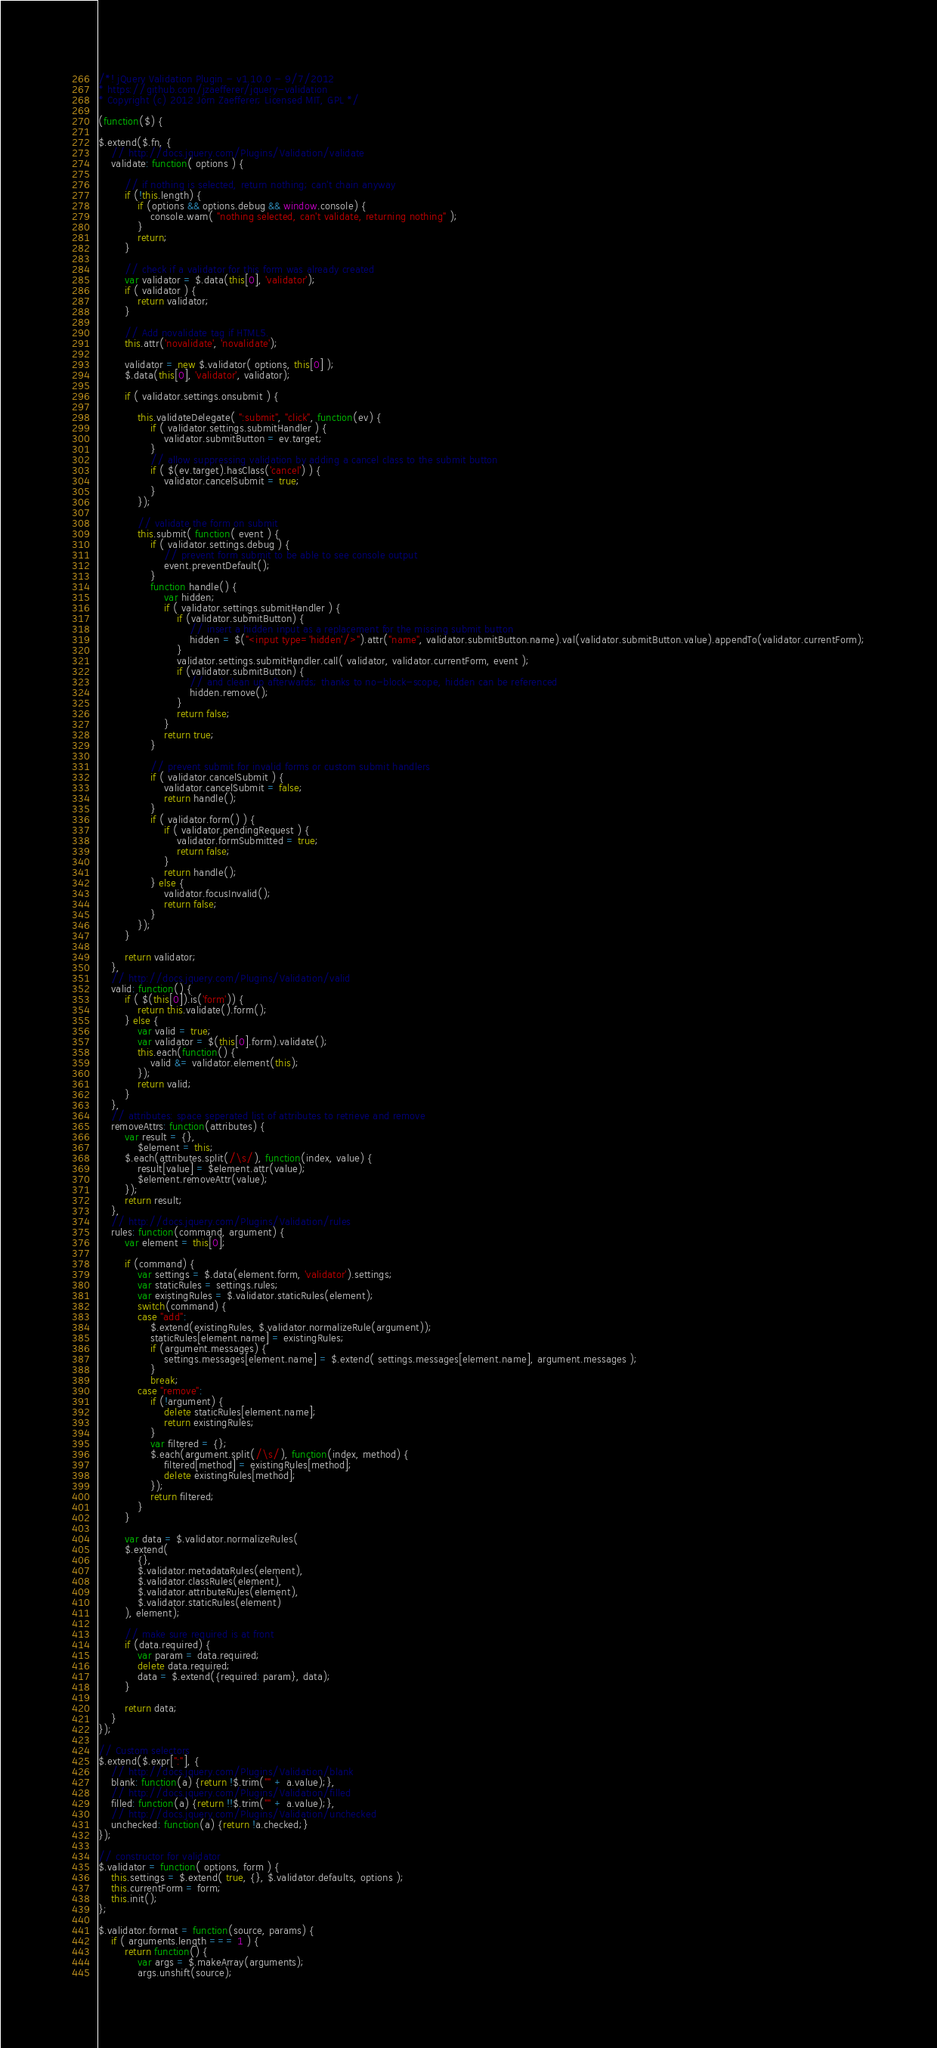Convert code to text. <code><loc_0><loc_0><loc_500><loc_500><_JavaScript_>/*! jQuery Validation Plugin - v1.10.0 - 9/7/2012
* https://github.com/jzaefferer/jquery-validation
* Copyright (c) 2012 Jörn Zaefferer; Licensed MIT, GPL */

(function($) {

$.extend($.fn, {
	// http://docs.jquery.com/Plugins/Validation/validate
	validate: function( options ) {

		// if nothing is selected, return nothing; can't chain anyway
		if (!this.length) {
			if (options && options.debug && window.console) {
				console.warn( "nothing selected, can't validate, returning nothing" );
			}
			return;
		}

		// check if a validator for this form was already created
		var validator = $.data(this[0], 'validator');
		if ( validator ) {
			return validator;
		}

		// Add novalidate tag if HTML5.
		this.attr('novalidate', 'novalidate');

		validator = new $.validator( options, this[0] );
		$.data(this[0], 'validator', validator);

		if ( validator.settings.onsubmit ) {

			this.validateDelegate( ":submit", "click", function(ev) {
				if ( validator.settings.submitHandler ) {
					validator.submitButton = ev.target;
				}
				// allow suppressing validation by adding a cancel class to the submit button
				if ( $(ev.target).hasClass('cancel') ) {
					validator.cancelSubmit = true;
				}
			});

			// validate the form on submit
			this.submit( function( event ) {
				if ( validator.settings.debug ) {
					// prevent form submit to be able to see console output
					event.preventDefault();
				}
				function handle() {
					var hidden;
					if ( validator.settings.submitHandler ) {
						if (validator.submitButton) {
							// insert a hidden input as a replacement for the missing submit button
							hidden = $("<input type='hidden'/>").attr("name", validator.submitButton.name).val(validator.submitButton.value).appendTo(validator.currentForm);
						}
						validator.settings.submitHandler.call( validator, validator.currentForm, event );
						if (validator.submitButton) {
							// and clean up afterwards; thanks to no-block-scope, hidden can be referenced
							hidden.remove();
						}
						return false;
					}
					return true;
				}

				// prevent submit for invalid forms or custom submit handlers
				if ( validator.cancelSubmit ) {
					validator.cancelSubmit = false;
					return handle();
				}
				if ( validator.form() ) {
					if ( validator.pendingRequest ) {
						validator.formSubmitted = true;
						return false;
					}
					return handle();
				} else {
					validator.focusInvalid();
					return false;
				}
			});
		}

		return validator;
	},
	// http://docs.jquery.com/Plugins/Validation/valid
	valid: function() {
		if ( $(this[0]).is('form')) {
			return this.validate().form();
		} else {
			var valid = true;
			var validator = $(this[0].form).validate();
			this.each(function() {
				valid &= validator.element(this);
			});
			return valid;
		}
	},
	// attributes: space seperated list of attributes to retrieve and remove
	removeAttrs: function(attributes) {
		var result = {},
			$element = this;
		$.each(attributes.split(/\s/), function(index, value) {
			result[value] = $element.attr(value);
			$element.removeAttr(value);
		});
		return result;
	},
	// http://docs.jquery.com/Plugins/Validation/rules
	rules: function(command, argument) {
		var element = this[0];

		if (command) {
			var settings = $.data(element.form, 'validator').settings;
			var staticRules = settings.rules;
			var existingRules = $.validator.staticRules(element);
			switch(command) {
			case "add":
				$.extend(existingRules, $.validator.normalizeRule(argument));
				staticRules[element.name] = existingRules;
				if (argument.messages) {
					settings.messages[element.name] = $.extend( settings.messages[element.name], argument.messages );
				}
				break;
			case "remove":
				if (!argument) {
					delete staticRules[element.name];
					return existingRules;
				}
				var filtered = {};
				$.each(argument.split(/\s/), function(index, method) {
					filtered[method] = existingRules[method];
					delete existingRules[method];
				});
				return filtered;
			}
		}

		var data = $.validator.normalizeRules(
		$.extend(
			{},
			$.validator.metadataRules(element),
			$.validator.classRules(element),
			$.validator.attributeRules(element),
			$.validator.staticRules(element)
		), element);

		// make sure required is at front
		if (data.required) {
			var param = data.required;
			delete data.required;
			data = $.extend({required: param}, data);
		}

		return data;
	}
});

// Custom selectors
$.extend($.expr[":"], {
	// http://docs.jquery.com/Plugins/Validation/blank
	blank: function(a) {return !$.trim("" + a.value);},
	// http://docs.jquery.com/Plugins/Validation/filled
	filled: function(a) {return !!$.trim("" + a.value);},
	// http://docs.jquery.com/Plugins/Validation/unchecked
	unchecked: function(a) {return !a.checked;}
});

// constructor for validator
$.validator = function( options, form ) {
	this.settings = $.extend( true, {}, $.validator.defaults, options );
	this.currentForm = form;
	this.init();
};

$.validator.format = function(source, params) {
	if ( arguments.length === 1 ) {
		return function() {
			var args = $.makeArray(arguments);
			args.unshift(source);</code> 